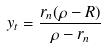Convert formula to latex. <formula><loc_0><loc_0><loc_500><loc_500>y _ { t } = \frac { r _ { n } ( \rho - R ) } { \rho - r _ { n } }</formula> 